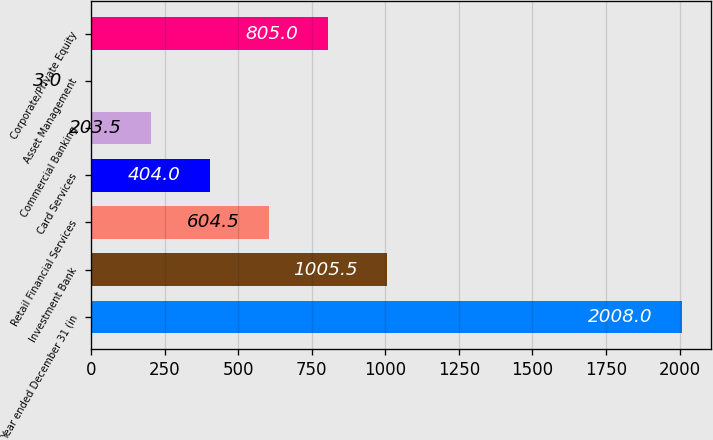<chart> <loc_0><loc_0><loc_500><loc_500><bar_chart><fcel>Year ended December 31 (in<fcel>Investment Bank<fcel>Retail Financial Services<fcel>Card Services<fcel>Commercial Banking<fcel>Asset Management<fcel>Corporate/Private Equity<nl><fcel>2008<fcel>1005.5<fcel>604.5<fcel>404<fcel>203.5<fcel>3<fcel>805<nl></chart> 